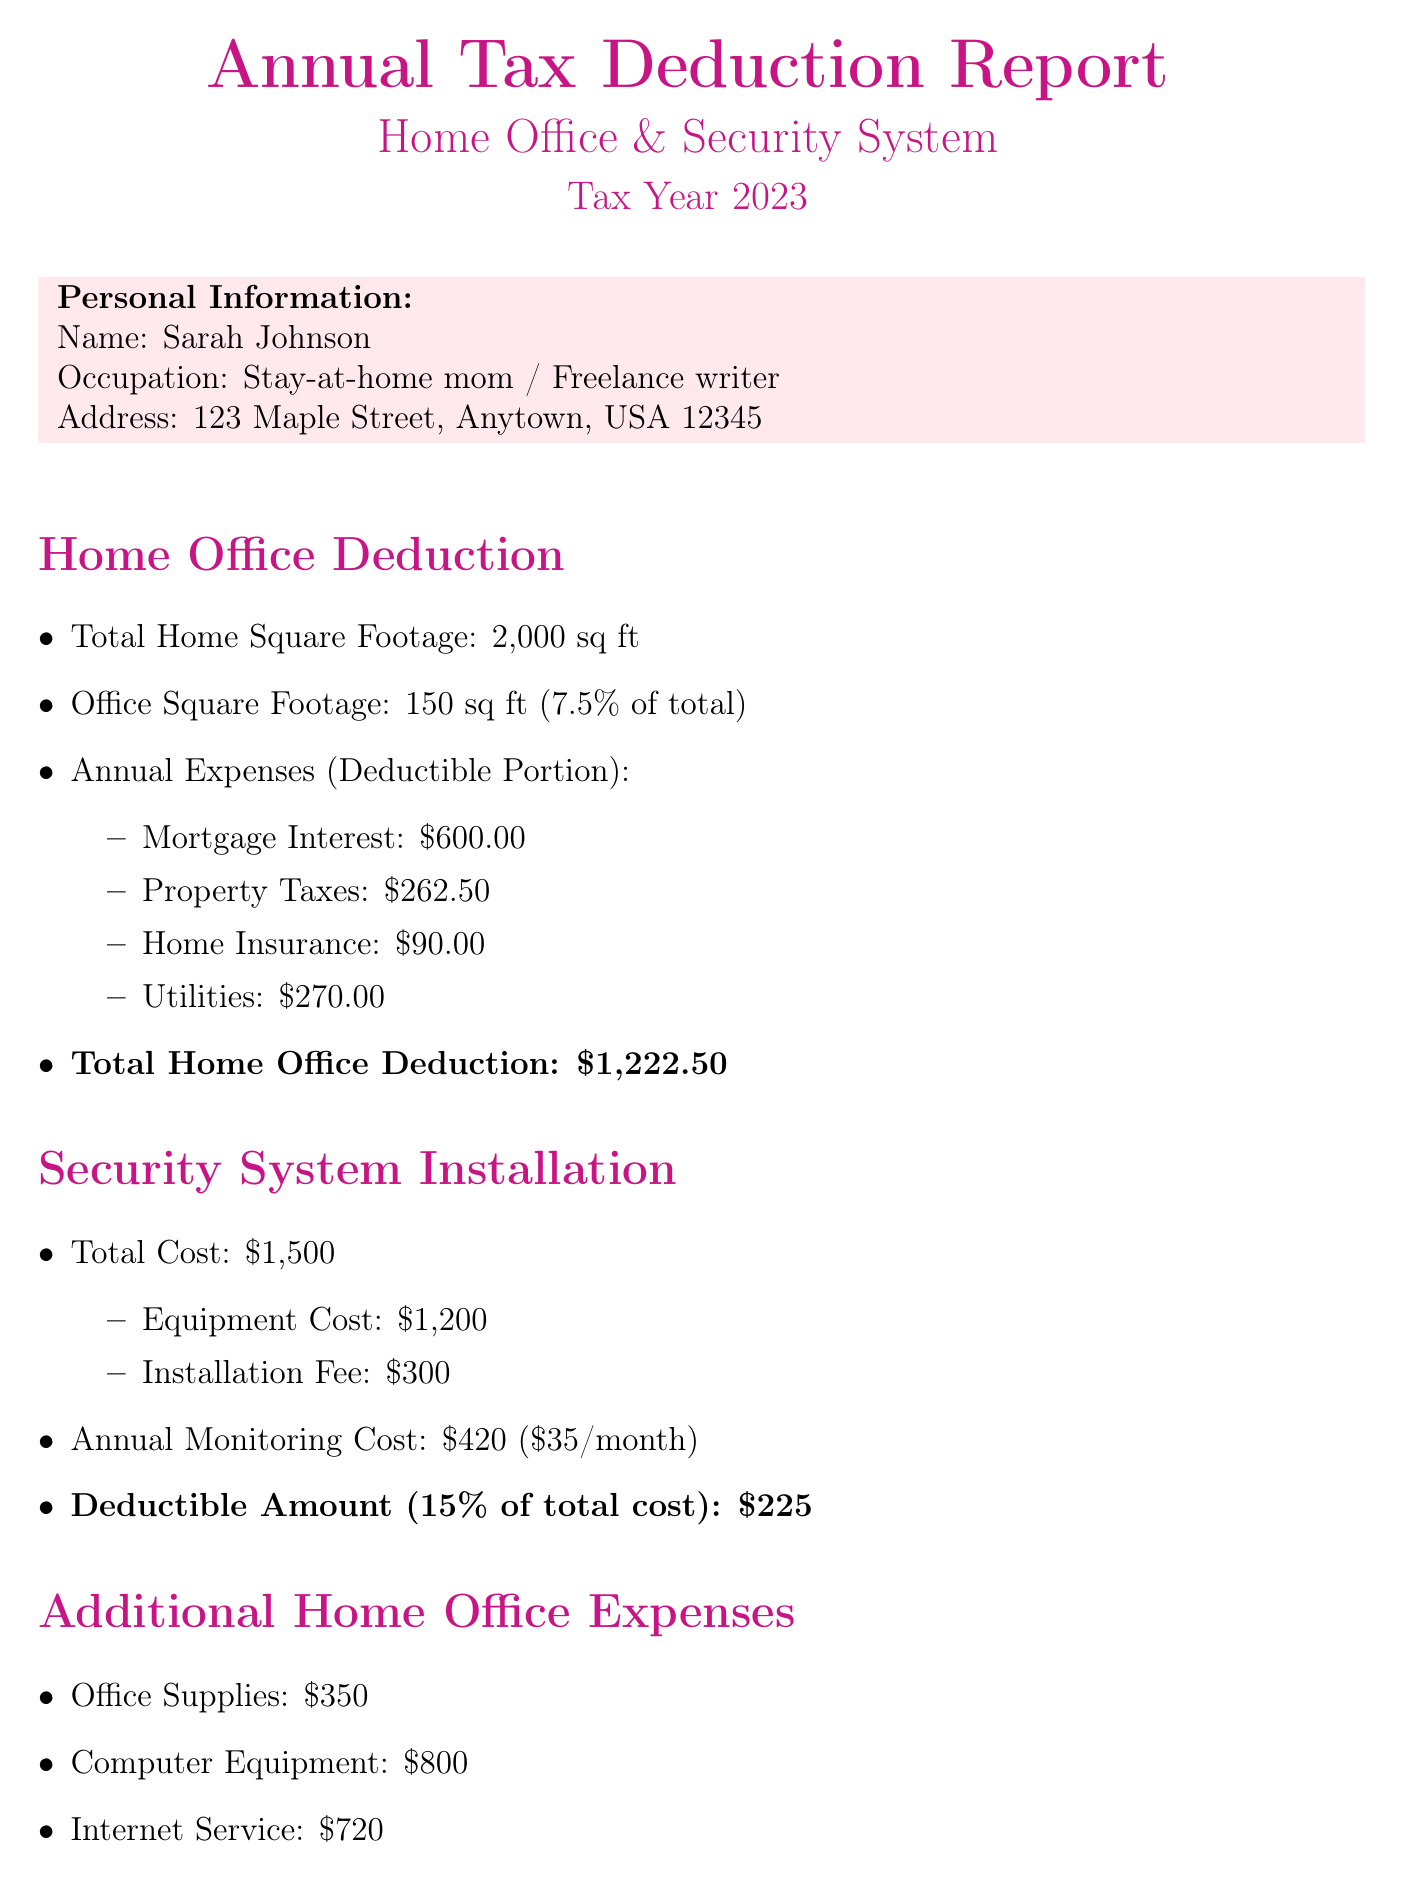What is the total square footage of the home? The total square footage of the home is mentioned in the document as 2,000 sq ft.
Answer: 2,000 sq ft What is the office square footage used for business? The square footage used for the home office is provided as 150 sq ft.
Answer: 150 sq ft What is the home office deduction total amount? The total amount for the home office deduction is explicitly stated in the report as \$1,222.50.
Answer: \$1,222.50 What percentage of the home is used for business purposes? The percentage of the home used for business is 7.5%, according to the document.
Answer: 7.5% What is the total cost of the security system installation? The total cost of the security system is given as \$1,500, which combines equipment and installation costs.
Answer: \$1,500 How much is the monthly monitoring fee for the security system? The document specifies that the monthly monitoring fee is \$35.
Answer: \$35 What is the total amount for additional home office expenses? The total additional expenses including supplies, equipment, and internet service add up to \$1,870.
Answer: \$1,870 What is the estimated total tax savings based on the tax rate? The estimated total tax savings, calculated from the given tax rate, is noted as approximately \$729.85.
Answer: \$729.85 What is the amount deductible for the security system? The document states that the deductible amount for the security system is \$225.
Answer: \$225 